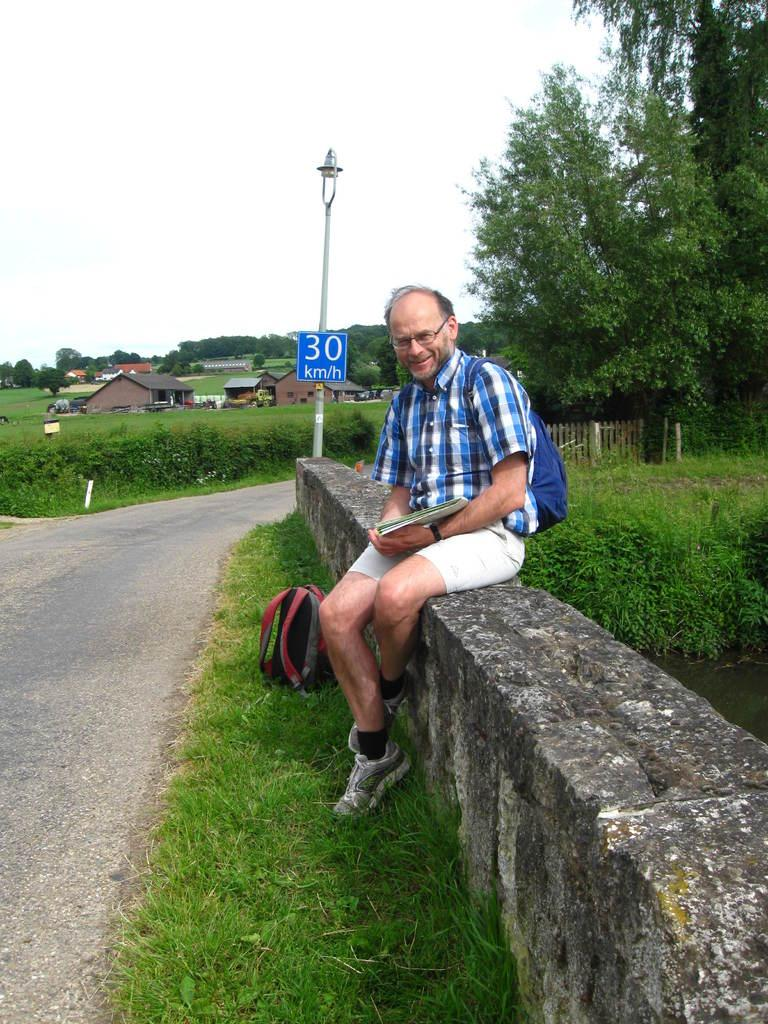Provide a one-sentence caption for the provided image. a man next to a sign with 30 on it. 